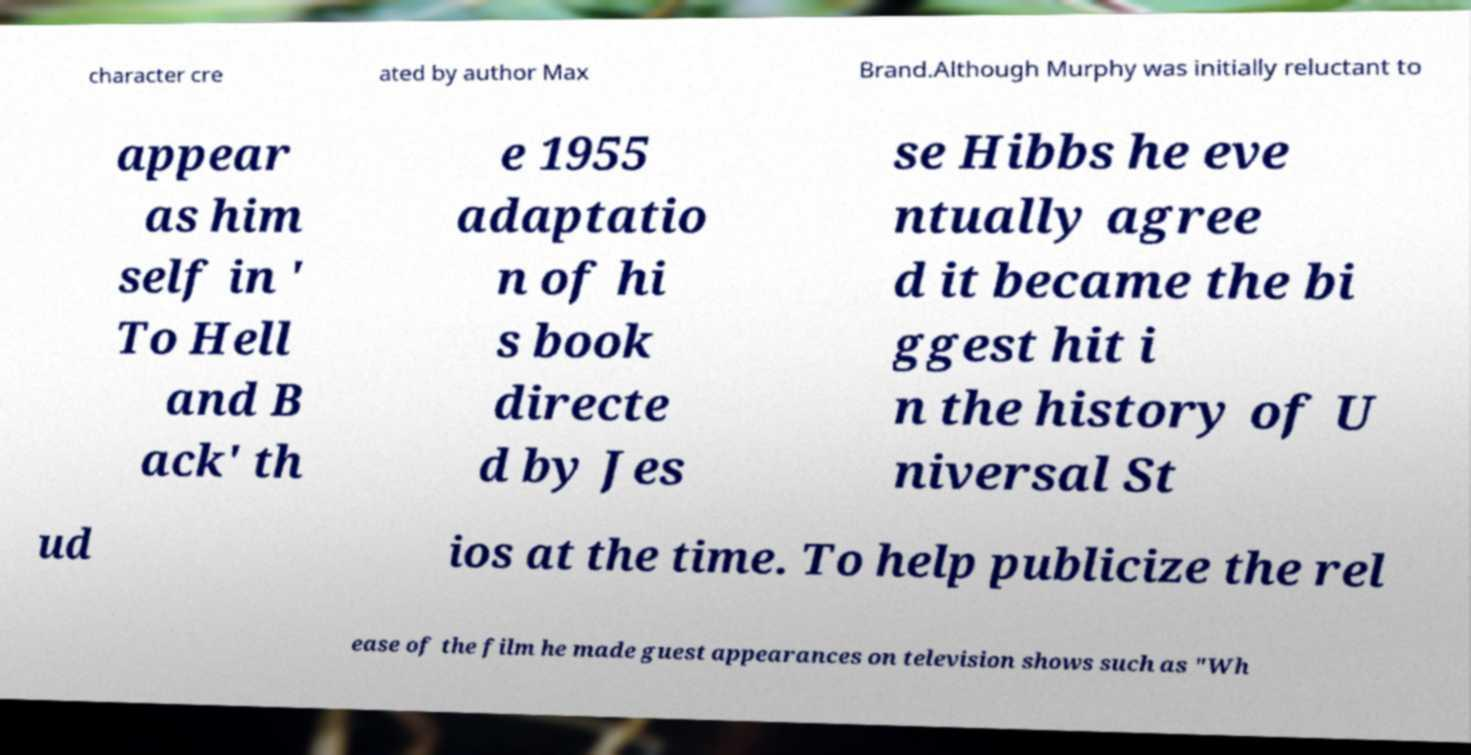There's text embedded in this image that I need extracted. Can you transcribe it verbatim? character cre ated by author Max Brand.Although Murphy was initially reluctant to appear as him self in ' To Hell and B ack' th e 1955 adaptatio n of hi s book directe d by Jes se Hibbs he eve ntually agree d it became the bi ggest hit i n the history of U niversal St ud ios at the time. To help publicize the rel ease of the film he made guest appearances on television shows such as "Wh 